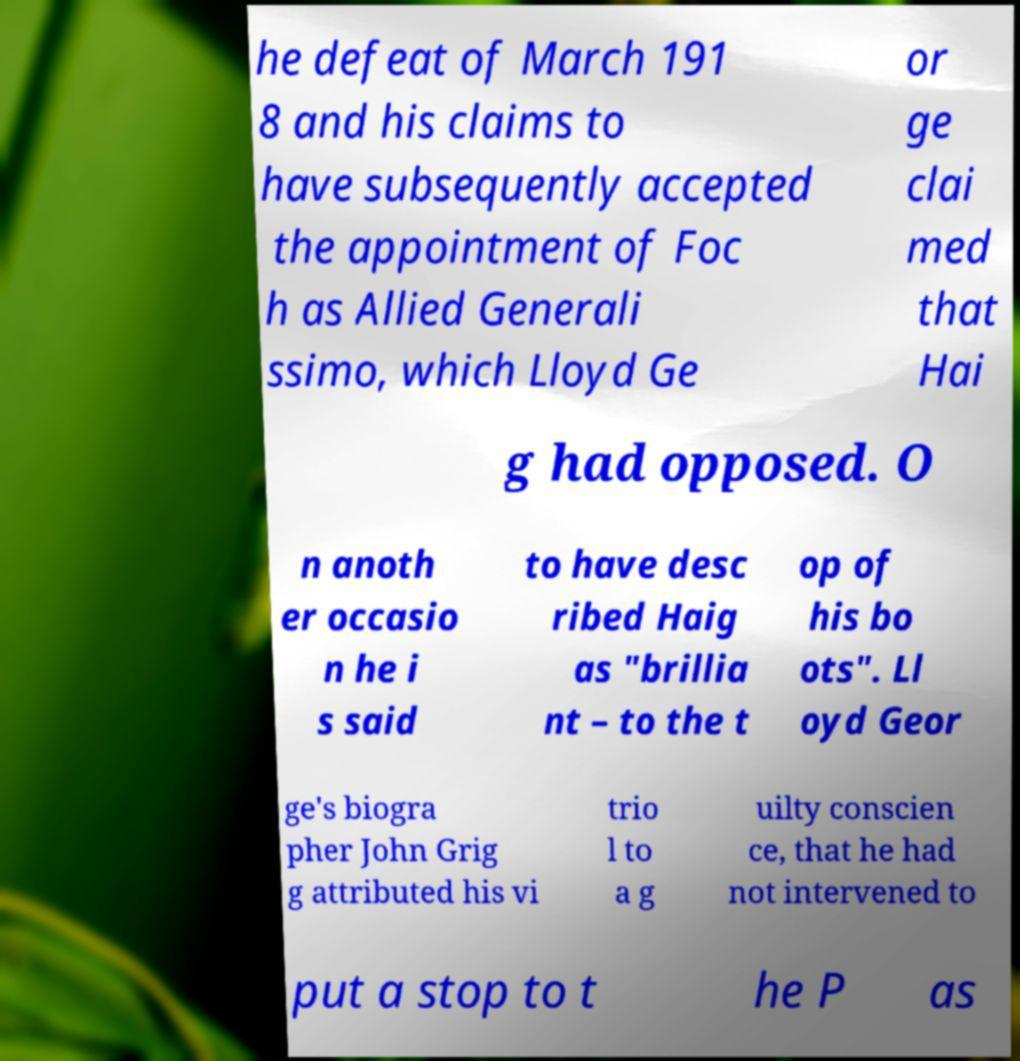Please read and relay the text visible in this image. What does it say? he defeat of March 191 8 and his claims to have subsequently accepted the appointment of Foc h as Allied Generali ssimo, which Lloyd Ge or ge clai med that Hai g had opposed. O n anoth er occasio n he i s said to have desc ribed Haig as "brillia nt – to the t op of his bo ots". Ll oyd Geor ge's biogra pher John Grig g attributed his vi trio l to a g uilty conscien ce, that he had not intervened to put a stop to t he P as 